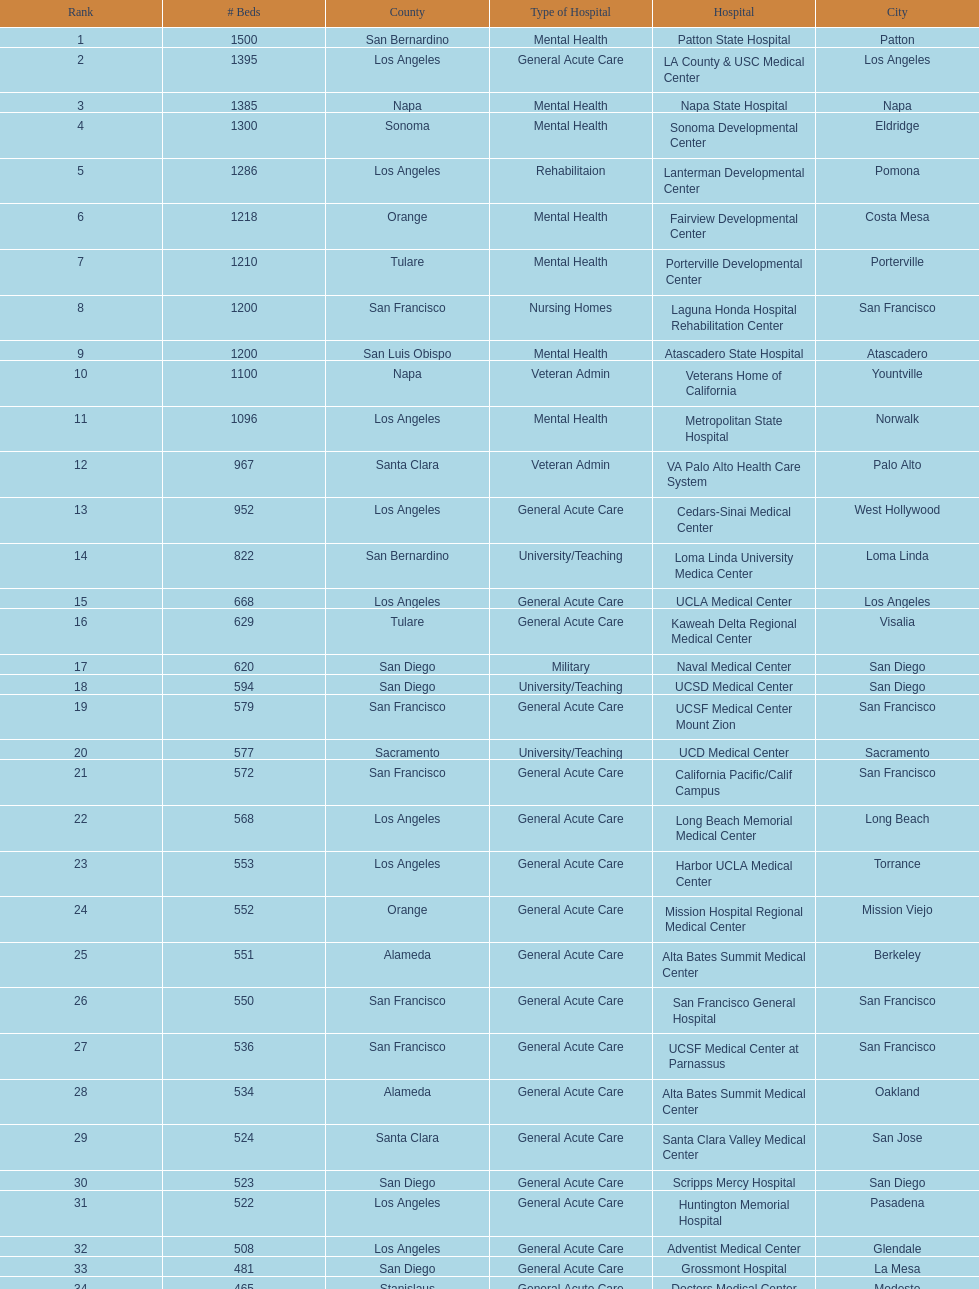How many hospital's have at least 600 beds? 17. 